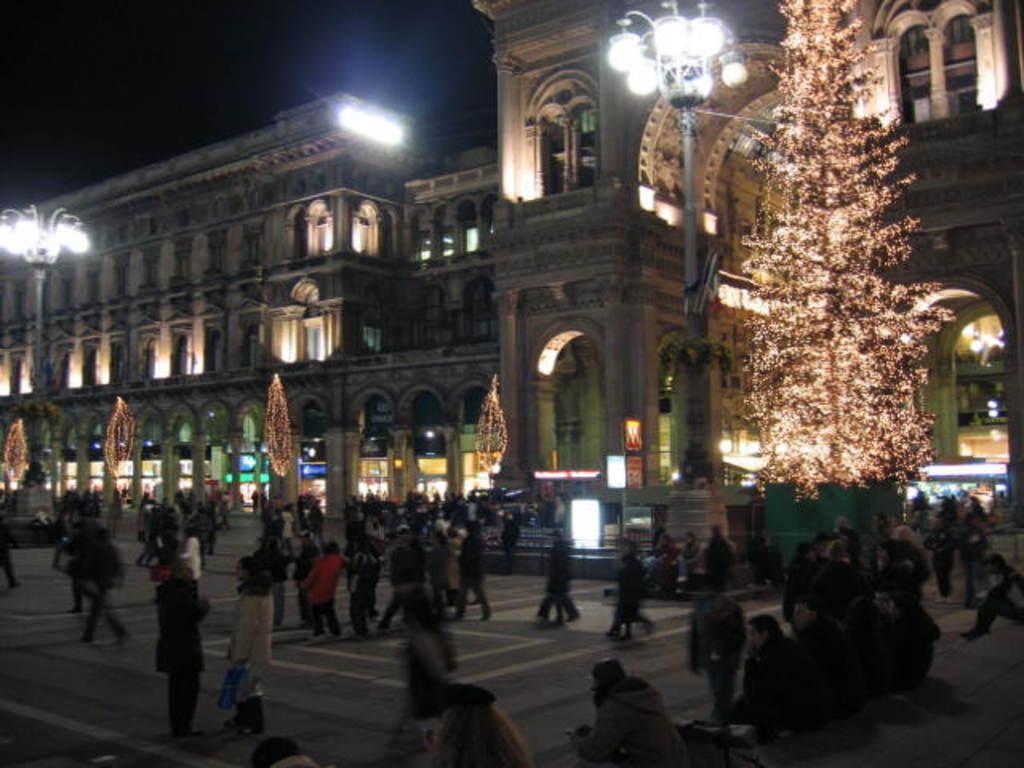Could you give a brief overview of what you see in this image? In this picture I can see the path in front on which there are number of people and in the middle of this picture I see the buildings and the lights and I see that it is dark in the background. 